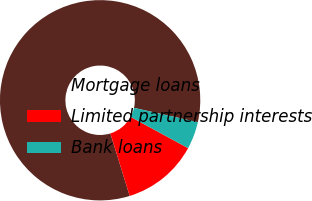Convert chart to OTSL. <chart><loc_0><loc_0><loc_500><loc_500><pie_chart><fcel>Mortgage loans<fcel>Limited partnership interests<fcel>Bank loans<nl><fcel>83.29%<fcel>12.3%<fcel>4.41%<nl></chart> 